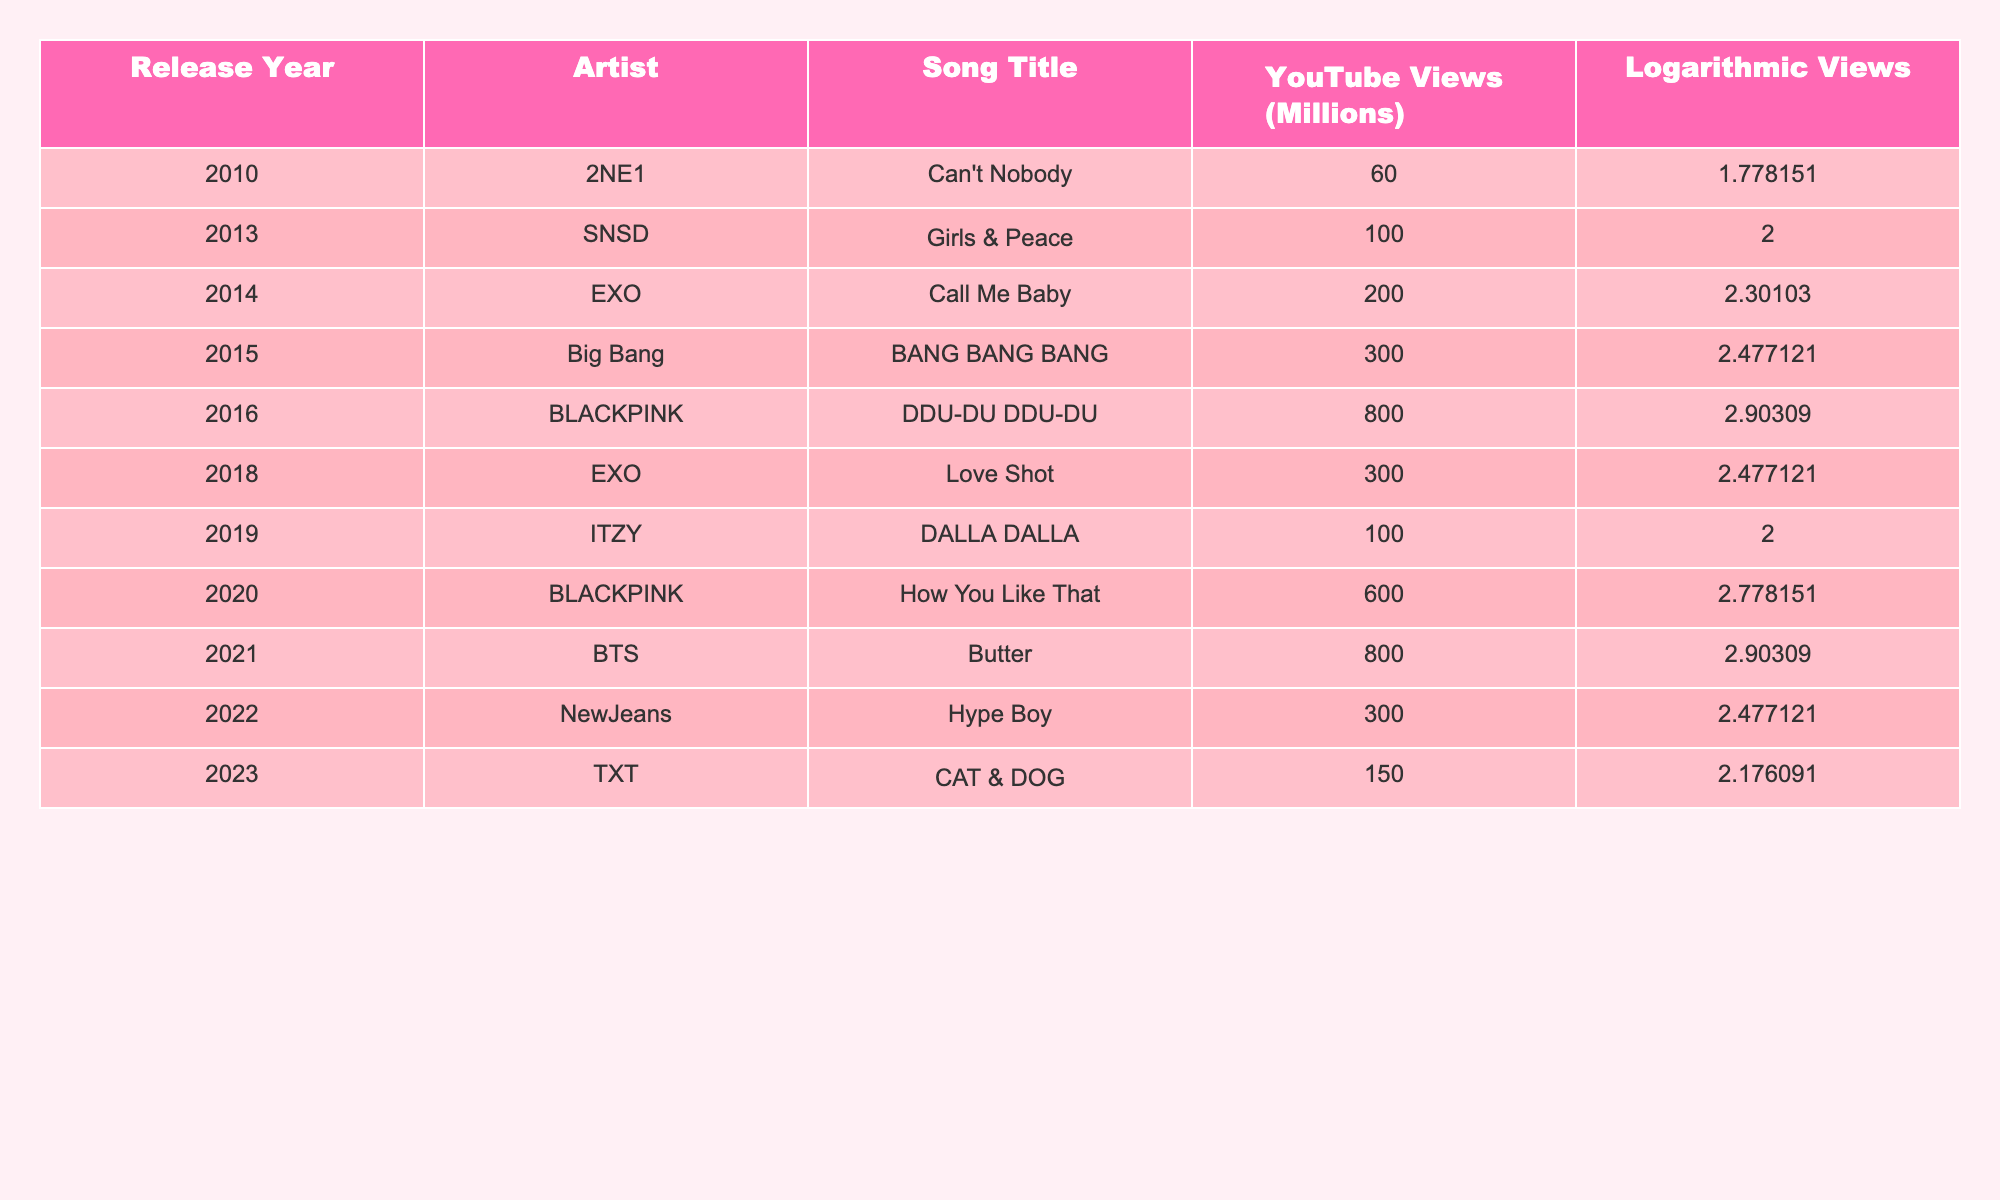What is the YouTube view count for BLACKPINK's "How You Like That"? From the table, under the artist BLACKPINK and the song title "How You Like That," the YouTube views are listed as 600 million.
Answer: 600 million Which song released in 2014 has the highest logarithmic view value? In 2014, EXO's "Call Me Baby" received a logarithmic views score of 2.301030, which is the highest for that year as per the table.
Answer: EXO's "Call Me Baby" What is the total number of YouTube views for songs released in 2021? Summing the views from the table for 2021: BTS's "Butter" (800 million). This is the only song listed in 2021, so the total is just 800 million.
Answer: 800 million Is it true that 2NE1's "Can't Nobody" has more views than ITZY's "DALLA DALLA"? In the table, "Can't Nobody" has 60 million views while "DALLA DALLA" has 100 million views. Since 60 million is less than 100 million, the statement is false.
Answer: False What is the difference in logarithmic values between the highest and lowest view counts in the table? The highest logarithmic value is 2.903090 (BLACKPINK's "DDU-DU DDU-DU" and BTS's "Butter") and the lowest is 1.778151 (2NE1's "Can't Nobody"). The difference is 2.903090 - 1.778151 = 1.124939.
Answer: 1.124939 Which artist matches both 800 million views and a logarithmic value of 2.903090? Referring to the table, both BLACKPINK ("DDU-DU DDU-DU") and BTS ("Butter") showcase an equal view count of 800 million and share a logarithmic score of 2.903090.
Answer: BLACKPINK and BTS How many artists have songs listed with views greater than 300 million? The artists with songs above 300 million views are BLACKPINK (600 million), Big Bang (300 million), EXO (800 million, 300 million), and BTS (800 million). Counting these unique artists gives us four: BLACKPINK, Big Bang, EXO, and BTS.
Answer: 4 What is the average view count for songs released in the years 2018 and 2019? The view counts for 2018 and 2019 are: EXO's "Love Shot" (300 million) and ITZY's "DALLA DALLA" (100 million). The sum is 300 + 100 = 400 million, then divide by 2 for the average, which equals 200 million.
Answer: 200 million 